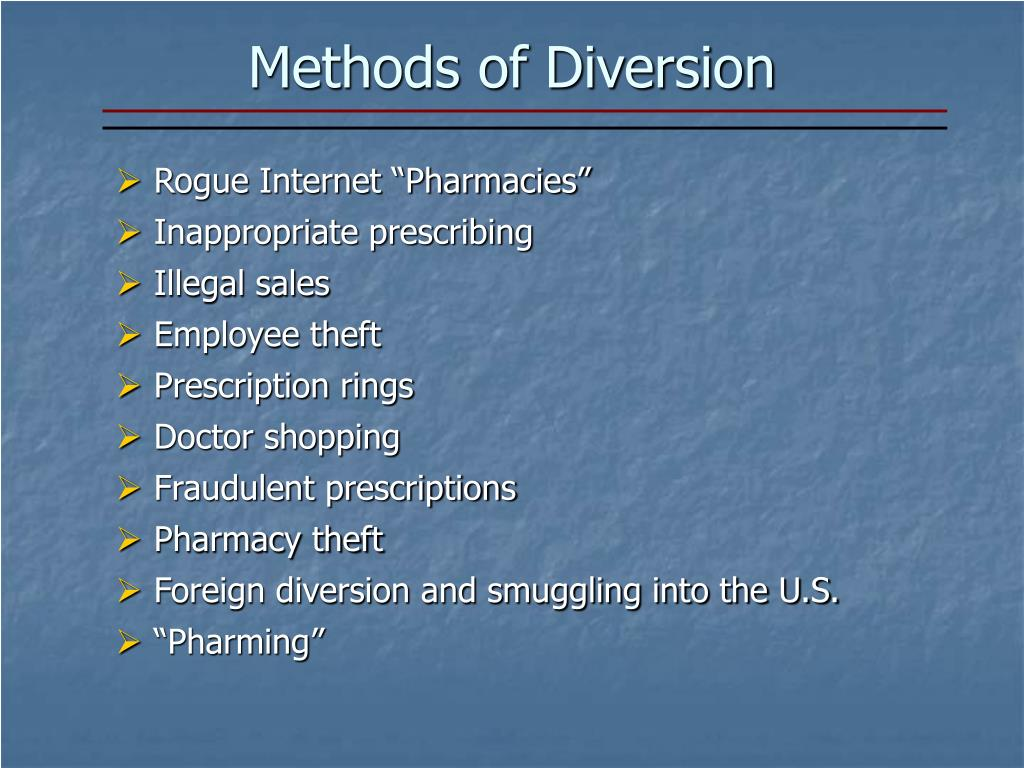Considering the context of the image, which method listed might be the most challenging to track and combat due to the international implications and the complexities of jurisdictional law enforcement cooperation? Based on the content shown in the image, the method 'Foreign diversion and smuggling into the U.S.' likely poses the greatest challenge to track and combat. This complexity arises from the international scope of the activity, necessitating cooperation among various countries' law enforcement agencies. Each country may have different legal frameworks and capabilities, making coordinated efforts difficult. Furthermore, differing national interests and priorities can impede seamless collaboration, increasing the challenge in addressing and controlling this method of diversion. 